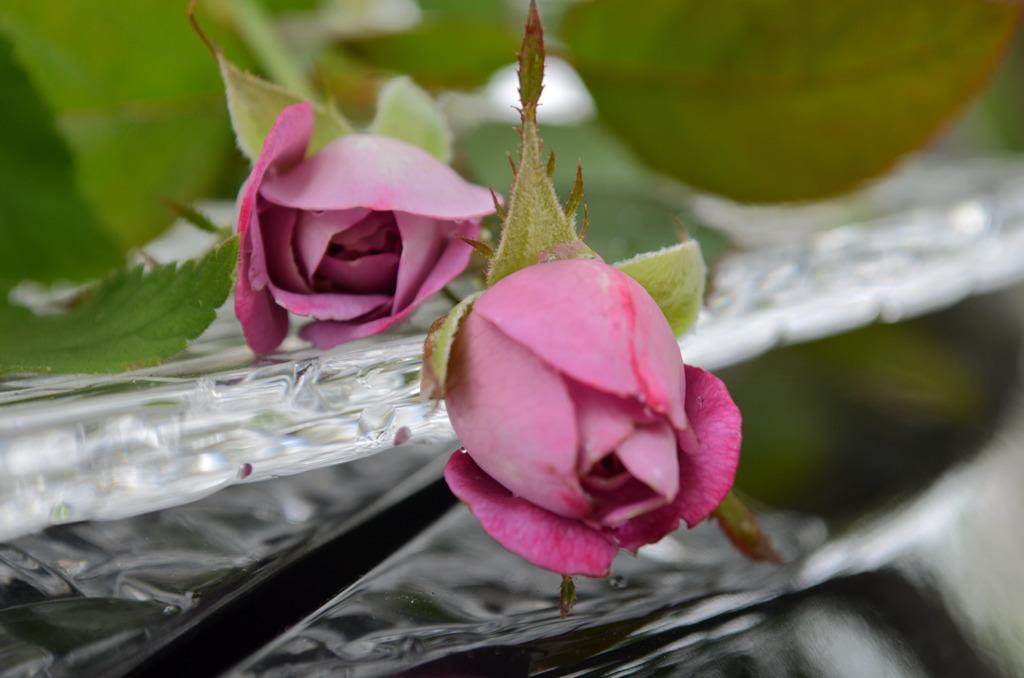How many rose flowers are in the image? There are two rose flowers in the image. What else can be seen on the rose flowers besides the petals? The rose flowers have leaves. What rhythm do the rose flowers follow in the image? There is no rhythm associated with the rose flowers in the image; they are stationary and not moving or changing. 